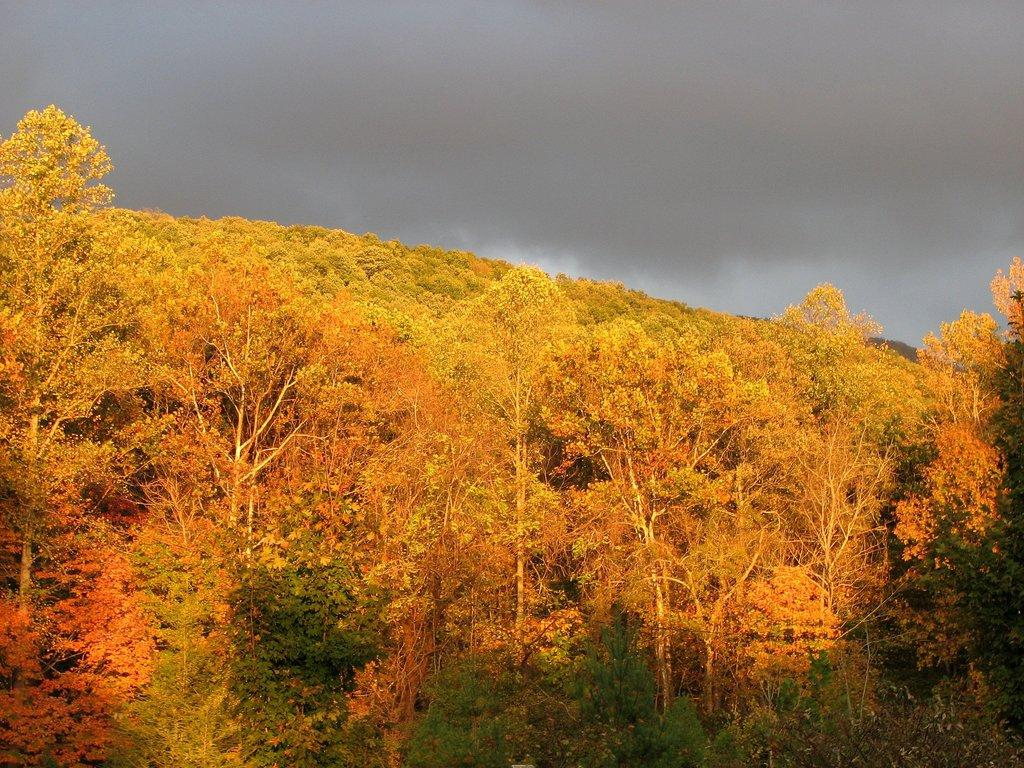What type of vegetation can be seen in the image? There are trees in the image. What can be seen in the sky in the image? There are clouds in the image. What type of crate is visible in the image? There is no crate present in the image. What machine is being used to twist the trees in the image? There is no machine or twisting of trees present in the image. 